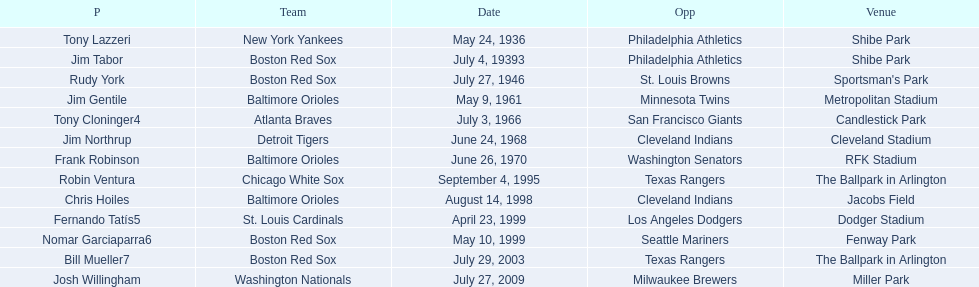Who are all the opponents? Philadelphia Athletics, Philadelphia Athletics, St. Louis Browns, Minnesota Twins, San Francisco Giants, Cleveland Indians, Washington Senators, Texas Rangers, Cleveland Indians, Los Angeles Dodgers, Seattle Mariners, Texas Rangers, Milwaukee Brewers. What teams played on july 27, 1946? Boston Red Sox, July 27, 1946, St. Louis Browns. Who was the opponent in this game? St. Louis Browns. 